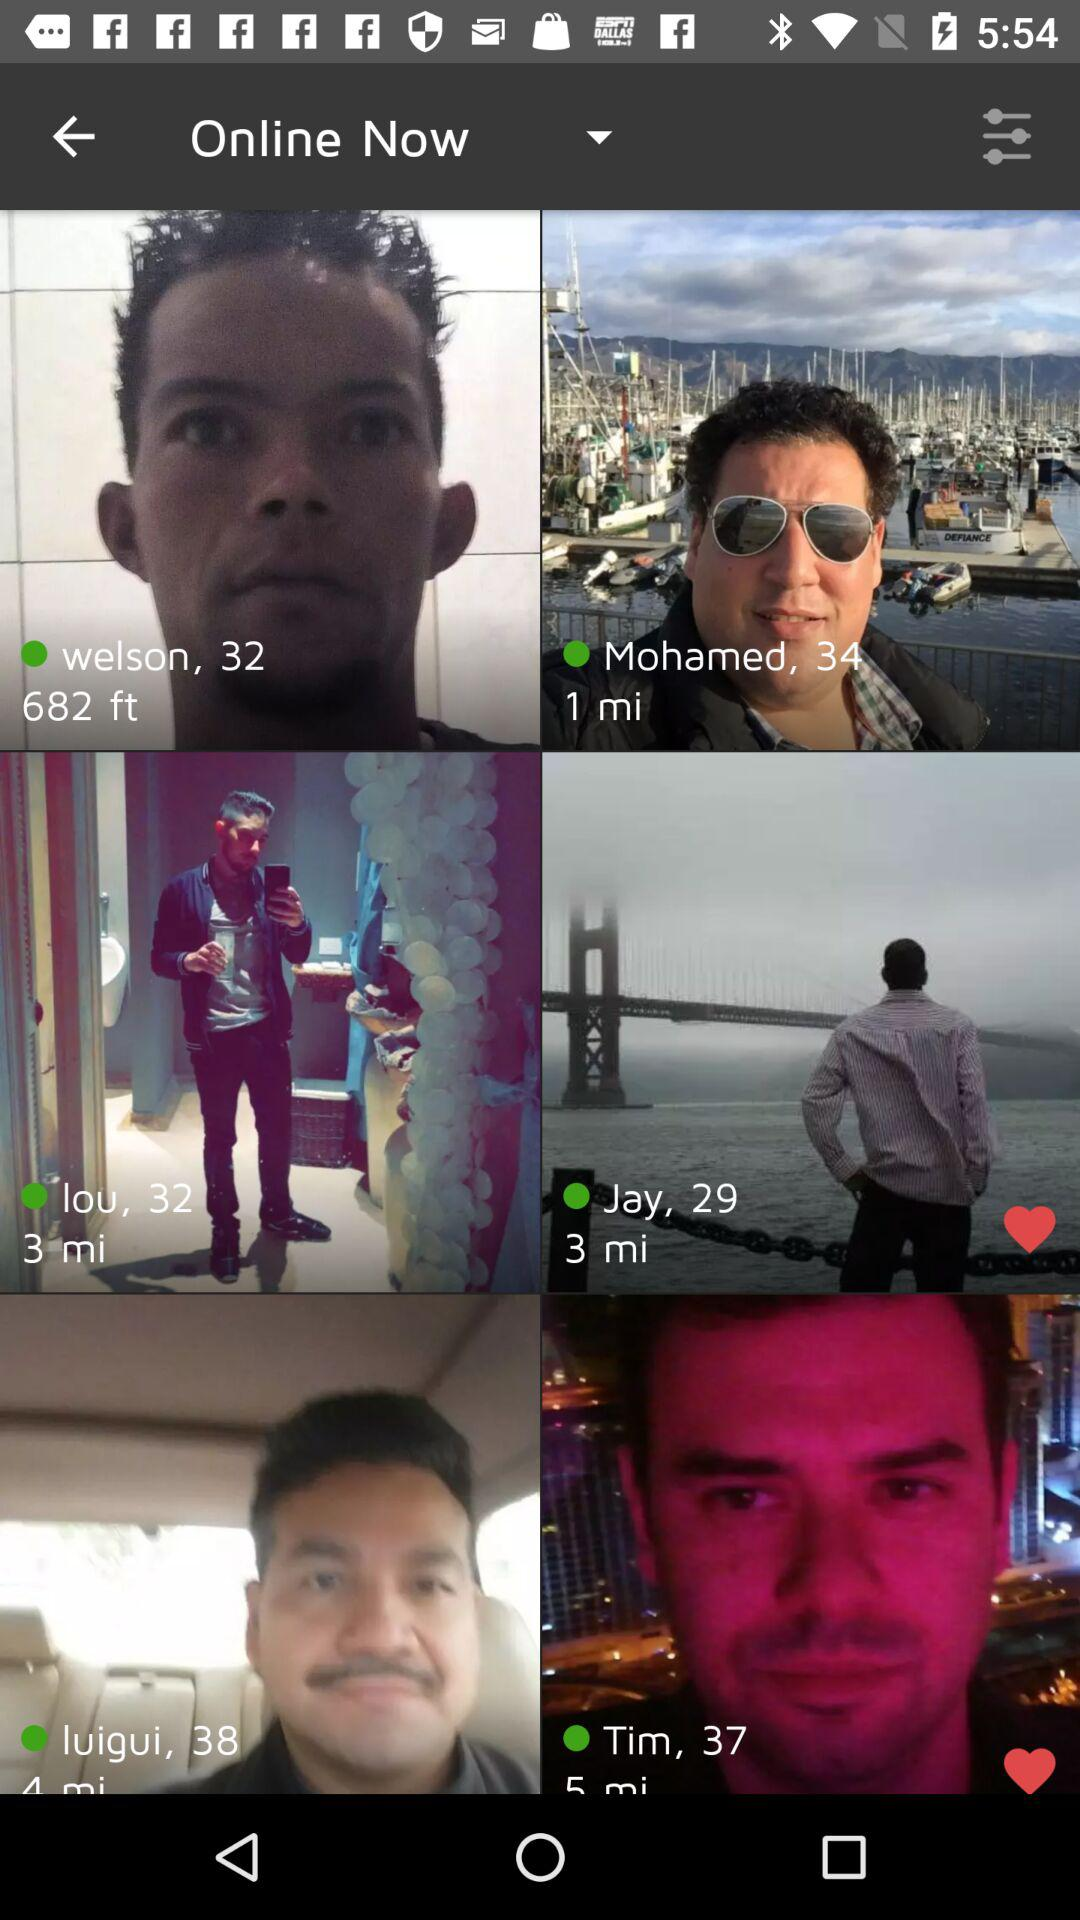At what distance is Jay from my location? Jay is 3 miles away from my location. 